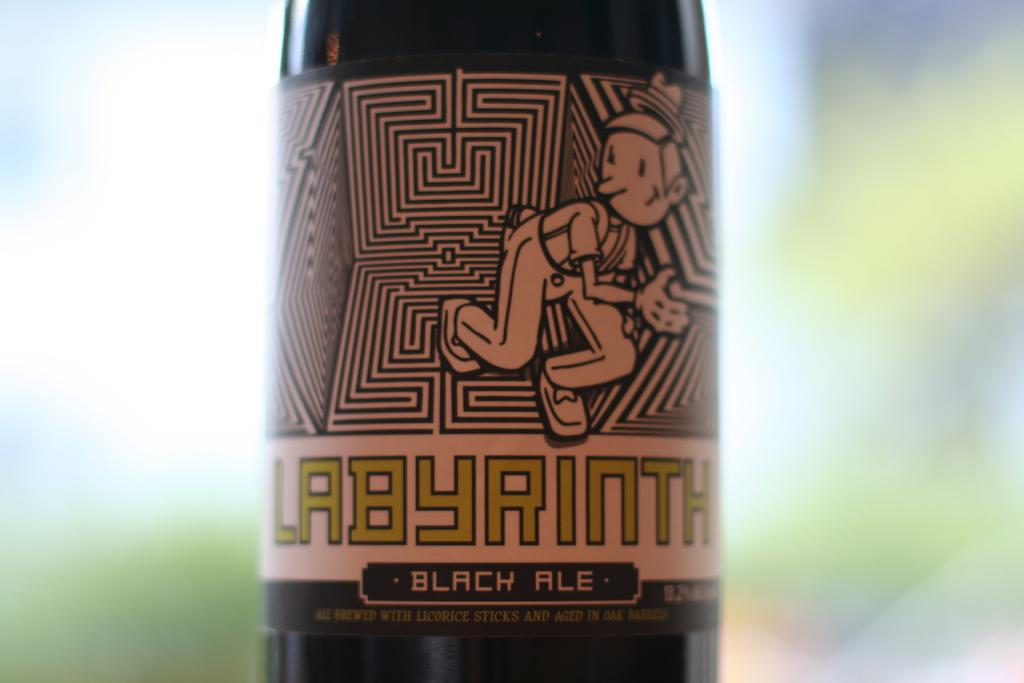What object can be seen in the image? There is a bottle in the image. What type of whistle can be heard in the image? There is no whistle present in the image, as it only features a bottle. How many letters are visible on the bottle in the image? The fact provided does not mention any letters on the bottle, so we cannot determine the number of letters visible. 